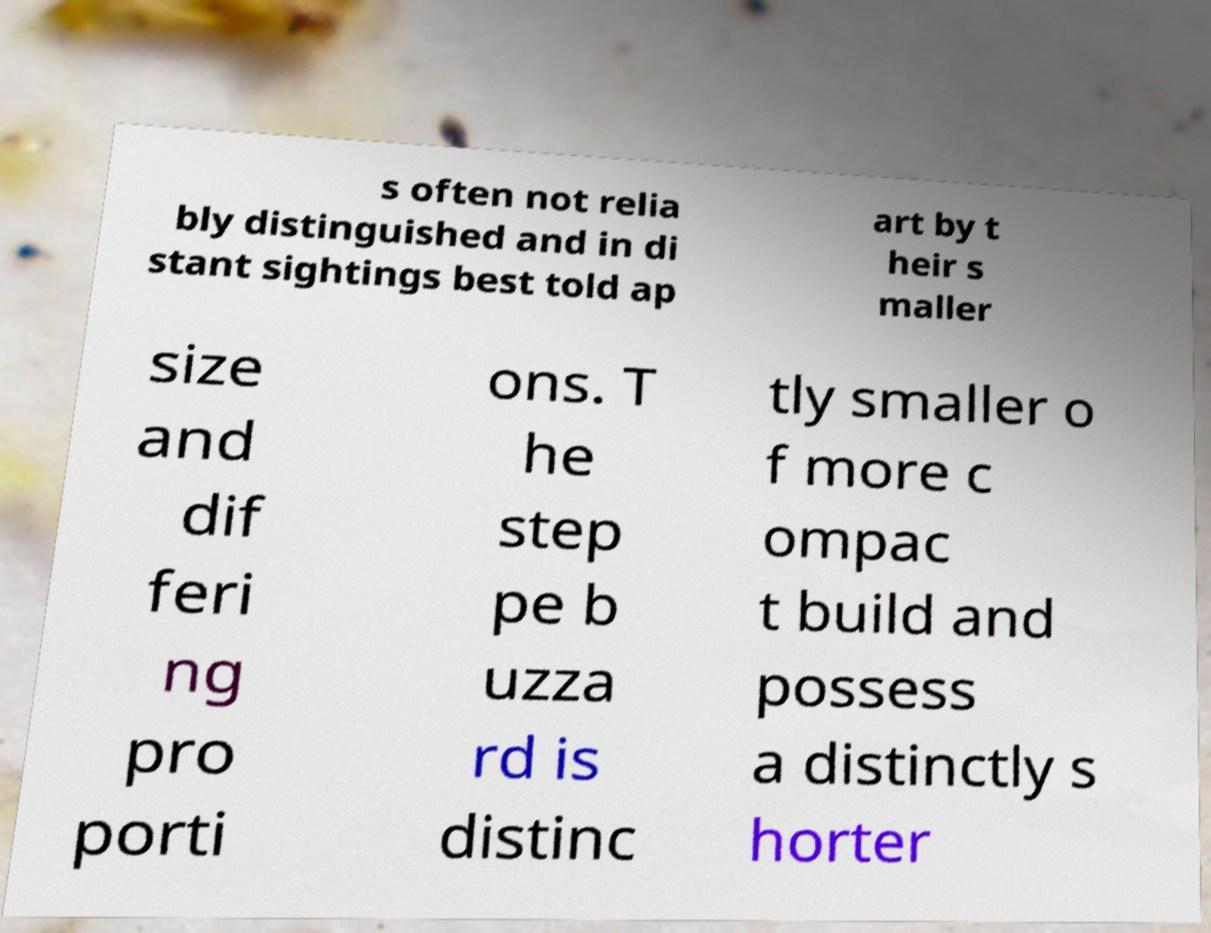What messages or text are displayed in this image? I need them in a readable, typed format. s often not relia bly distinguished and in di stant sightings best told ap art by t heir s maller size and dif feri ng pro porti ons. T he step pe b uzza rd is distinc tly smaller o f more c ompac t build and possess a distinctly s horter 